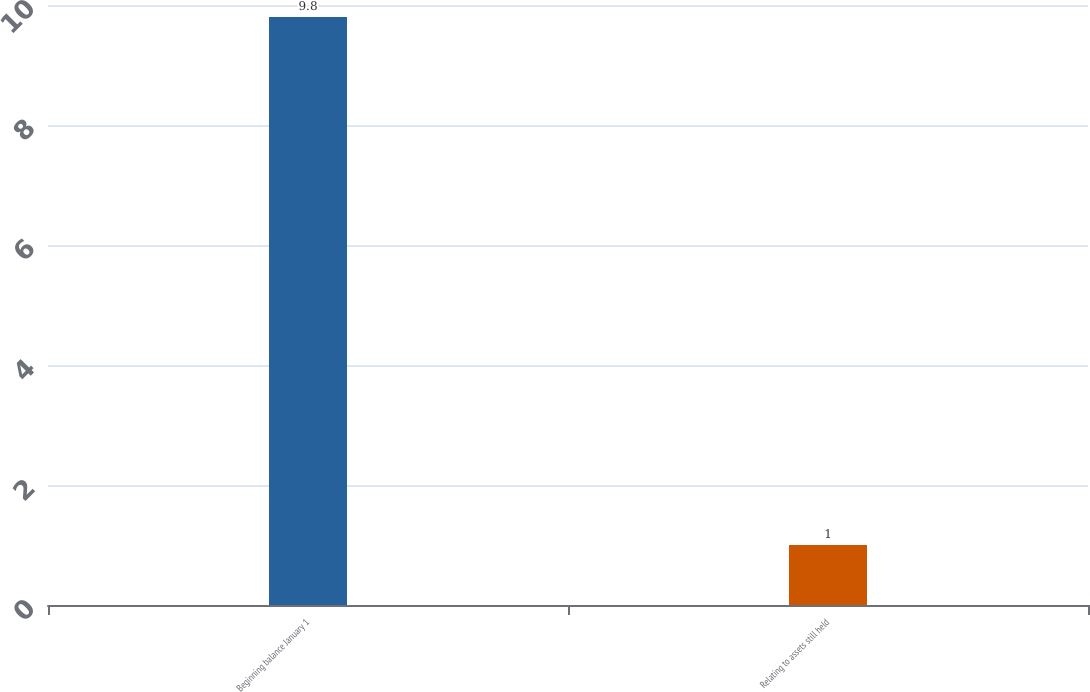Convert chart. <chart><loc_0><loc_0><loc_500><loc_500><bar_chart><fcel>Beginning balance January 1<fcel>Relating to assets still held<nl><fcel>9.8<fcel>1<nl></chart> 